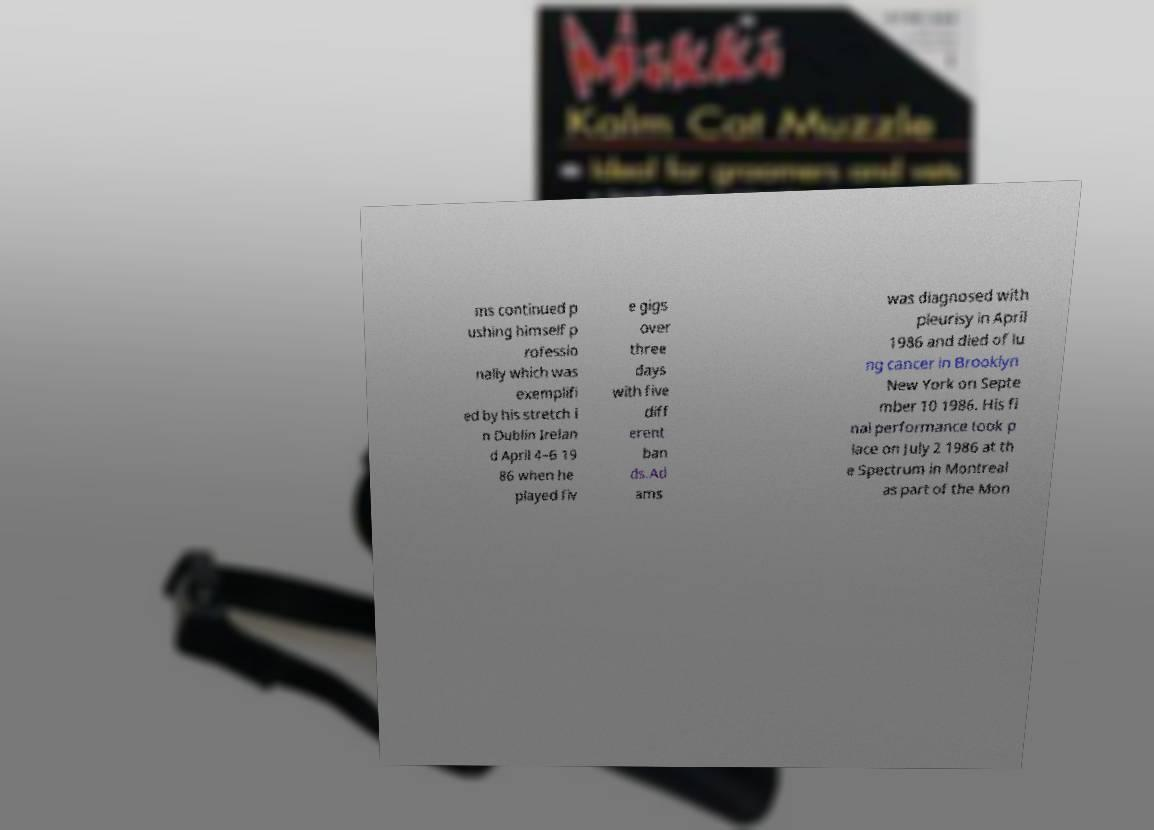For documentation purposes, I need the text within this image transcribed. Could you provide that? ms continued p ushing himself p rofessio nally which was exemplifi ed by his stretch i n Dublin Irelan d April 4–6 19 86 when he played fiv e gigs over three days with five diff erent ban ds.Ad ams was diagnosed with pleurisy in April 1986 and died of lu ng cancer in Brooklyn New York on Septe mber 10 1986. His fi nal performance took p lace on July 2 1986 at th e Spectrum in Montreal as part of the Mon 